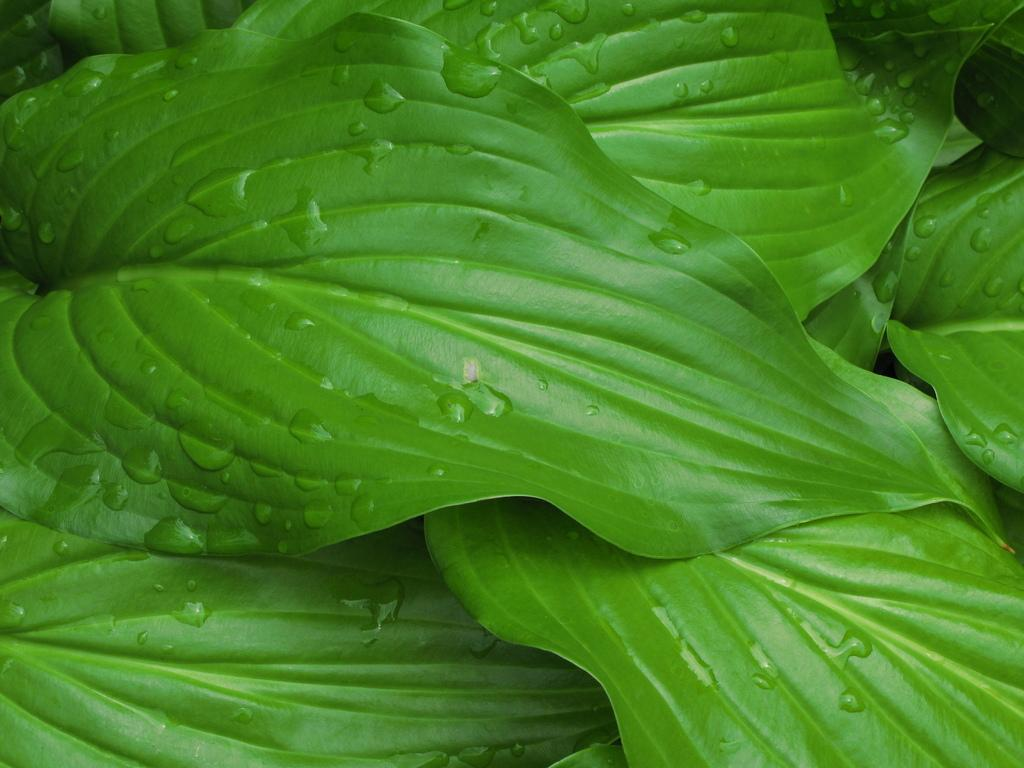What type of vegetation can be seen in the image? There are leaves in the image. Can you describe the condition of the leaves? Water droplets are present on the leaves in the image. What color is the brick in the image? There is no brick present in the image; it only features leaves with water droplets. 